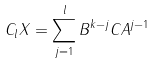Convert formula to latex. <formula><loc_0><loc_0><loc_500><loc_500>C _ { l } X = \sum _ { j = 1 } ^ { l } B ^ { k - j } C A ^ { j - 1 }</formula> 